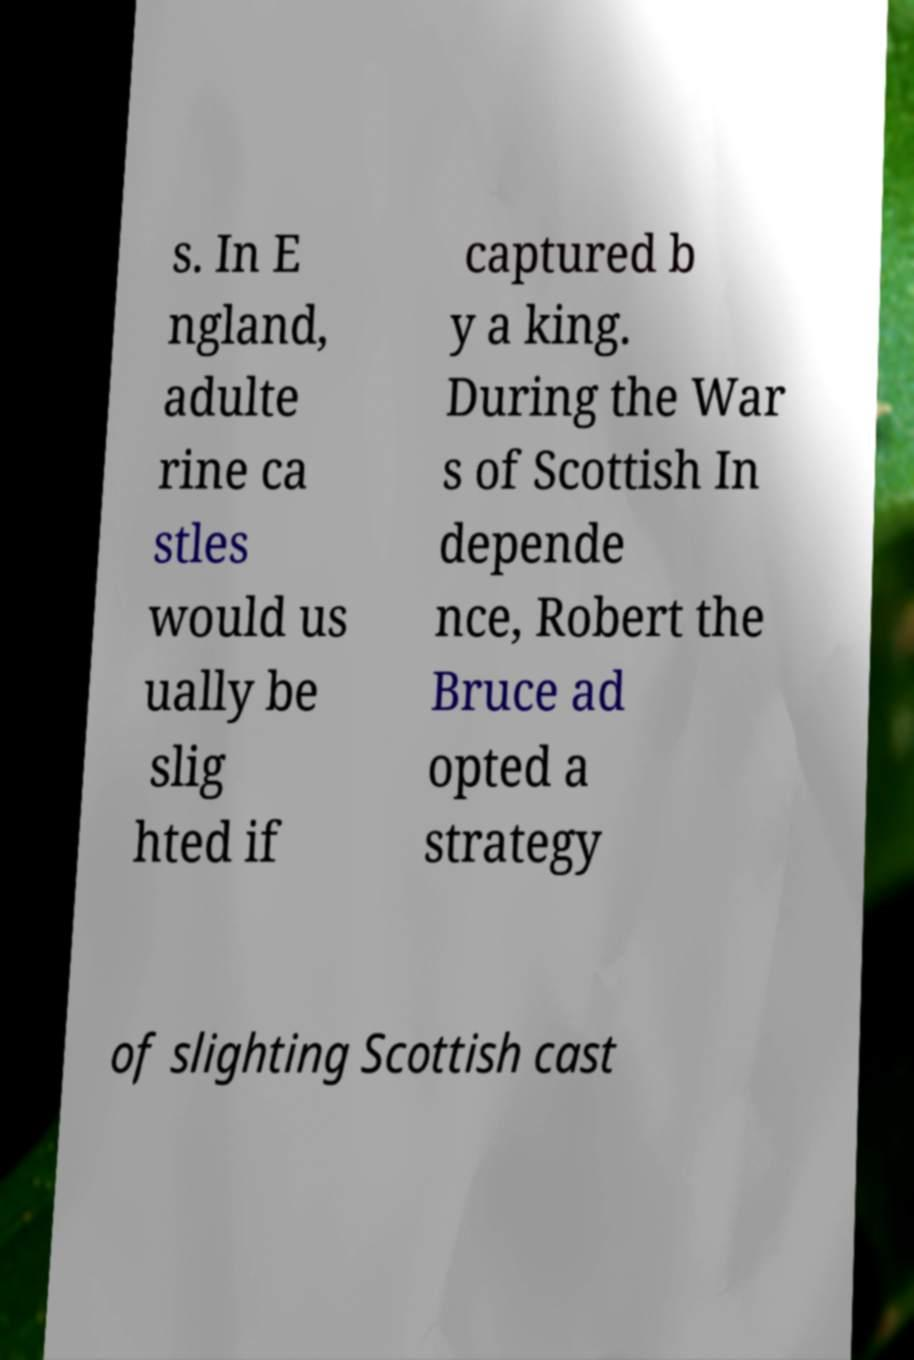What messages or text are displayed in this image? I need them in a readable, typed format. s. In E ngland, adulte rine ca stles would us ually be slig hted if captured b y a king. During the War s of Scottish In depende nce, Robert the Bruce ad opted a strategy of slighting Scottish cast 